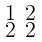Convert formula to latex. <formula><loc_0><loc_0><loc_500><loc_500>\begin{smallmatrix} 1 & 2 \\ 2 & 2 \end{smallmatrix}</formula> 